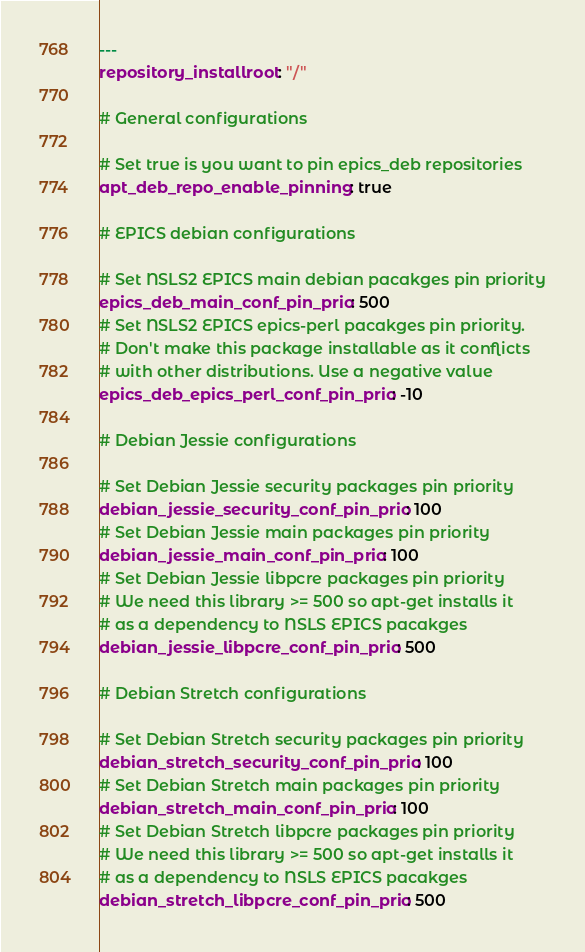<code> <loc_0><loc_0><loc_500><loc_500><_YAML_>---
repository_installroot: "/"

# General configurations

# Set true is you want to pin epics_deb repositories
apt_deb_repo_enable_pinning: true

# EPICS debian configurations

# Set NSLS2 EPICS main debian pacakges pin priority
epics_deb_main_conf_pin_prio: 500
# Set NSLS2 EPICS epics-perl pacakges pin priority.
# Don't make this package installable as it conflicts
# with other distributions. Use a negative value
epics_deb_epics_perl_conf_pin_prio: -10

# Debian Jessie configurations

# Set Debian Jessie security packages pin priority
debian_jessie_security_conf_pin_prio: 100
# Set Debian Jessie main packages pin priority
debian_jessie_main_conf_pin_prio: 100
# Set Debian Jessie libpcre packages pin priority
# We need this library >= 500 so apt-get installs it
# as a dependency to NSLS EPICS pacakges
debian_jessie_libpcre_conf_pin_prio: 500

# Debian Stretch configurations

# Set Debian Stretch security packages pin priority
debian_stretch_security_conf_pin_prio: 100
# Set Debian Stretch main packages pin priority
debian_stretch_main_conf_pin_prio: 100
# Set Debian Stretch libpcre packages pin priority
# We need this library >= 500 so apt-get installs it
# as a dependency to NSLS EPICS pacakges
debian_stretch_libpcre_conf_pin_prio: 500
</code> 